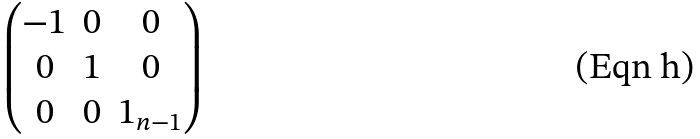<formula> <loc_0><loc_0><loc_500><loc_500>\begin{pmatrix} - 1 & 0 & 0 \\ 0 & 1 & 0 \\ 0 & 0 & 1 _ { n - 1 } \end{pmatrix}</formula> 